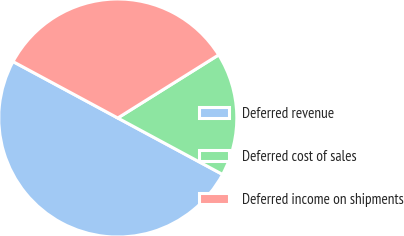Convert chart to OTSL. <chart><loc_0><loc_0><loc_500><loc_500><pie_chart><fcel>Deferred revenue<fcel>Deferred cost of sales<fcel>Deferred income on shipments<nl><fcel>50.0%<fcel>16.76%<fcel>33.24%<nl></chart> 